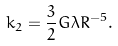Convert formula to latex. <formula><loc_0><loc_0><loc_500><loc_500>k _ { 2 } = \frac { 3 } { 2 } G \lambda R ^ { - 5 } .</formula> 